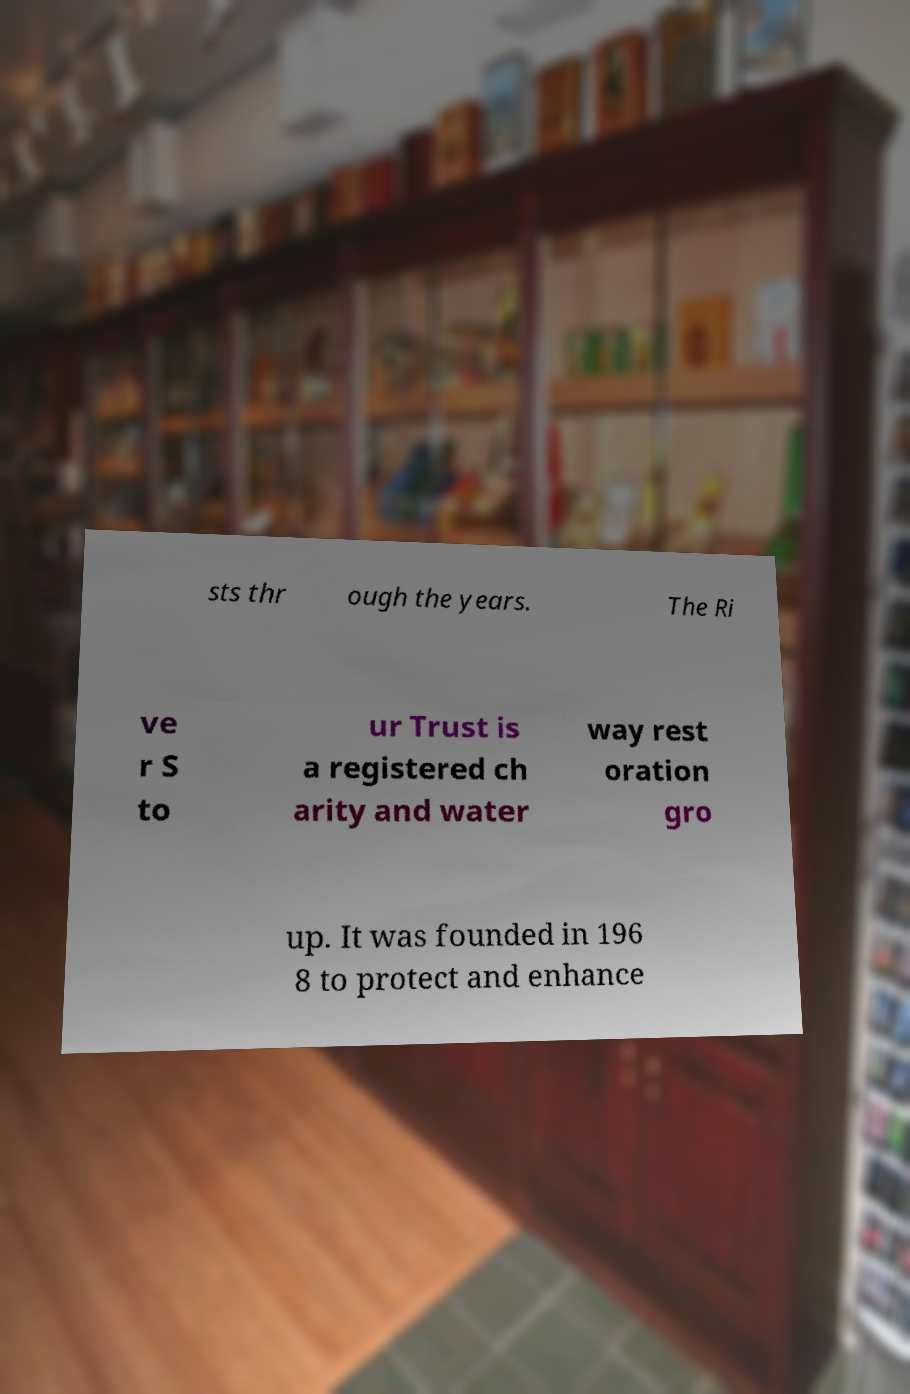Could you extract and type out the text from this image? sts thr ough the years. The Ri ve r S to ur Trust is a registered ch arity and water way rest oration gro up. It was founded in 196 8 to protect and enhance 